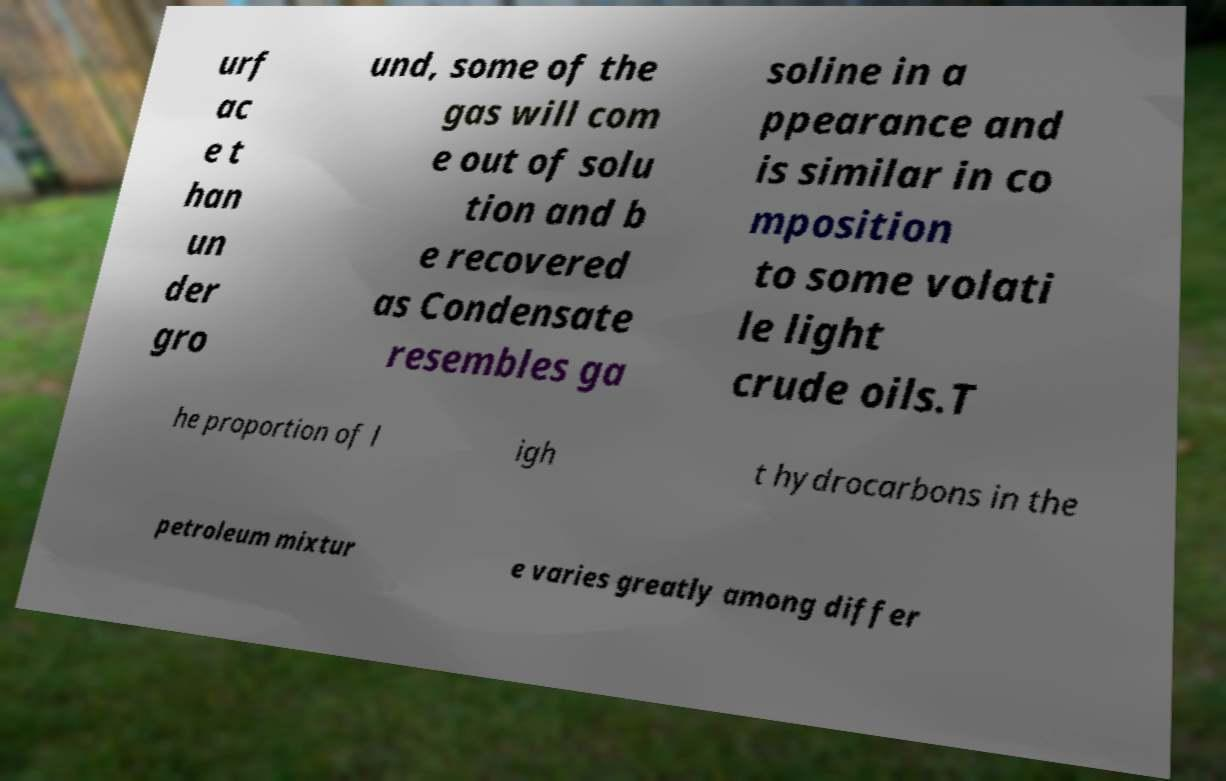I need the written content from this picture converted into text. Can you do that? urf ac e t han un der gro und, some of the gas will com e out of solu tion and b e recovered as Condensate resembles ga soline in a ppearance and is similar in co mposition to some volati le light crude oils.T he proportion of l igh t hydrocarbons in the petroleum mixtur e varies greatly among differ 